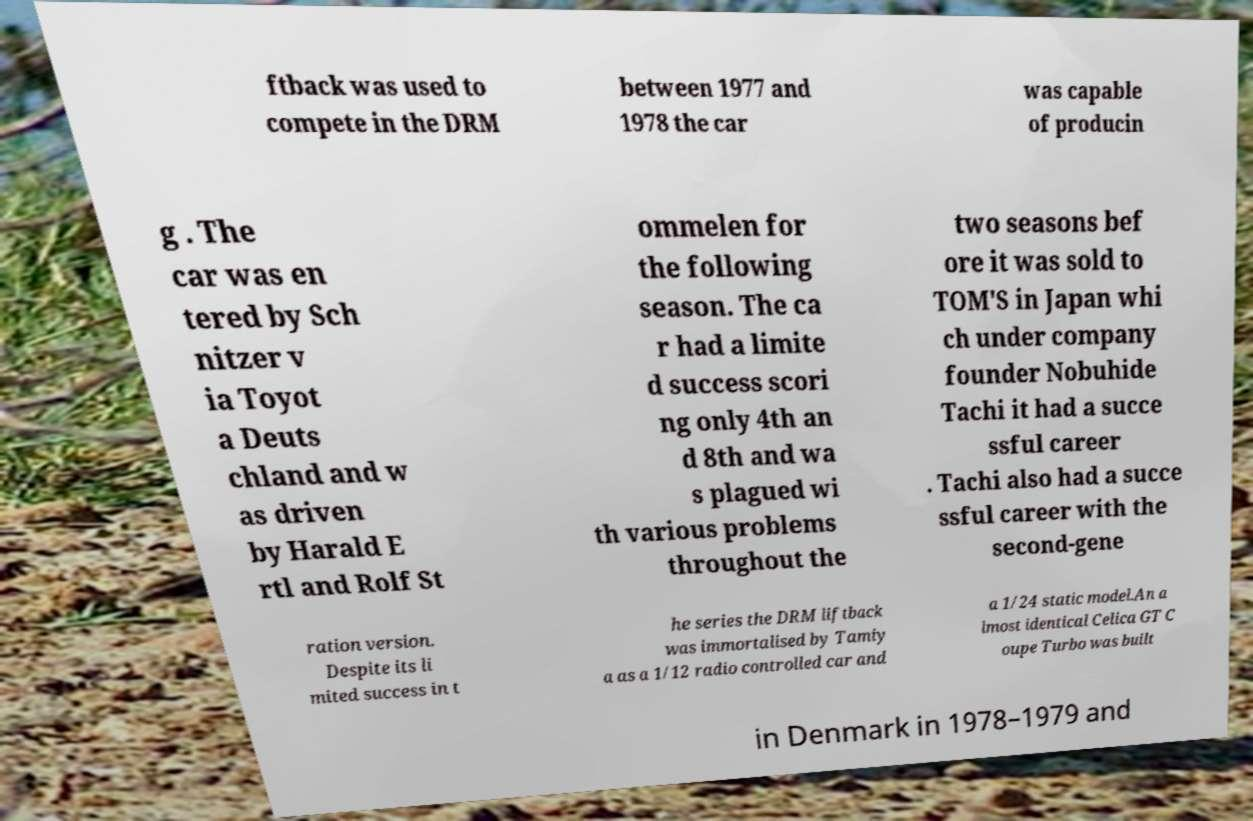Can you accurately transcribe the text from the provided image for me? ftback was used to compete in the DRM between 1977 and 1978 the car was capable of producin g . The car was en tered by Sch nitzer v ia Toyot a Deuts chland and w as driven by Harald E rtl and Rolf St ommelen for the following season. The ca r had a limite d success scori ng only 4th an d 8th and wa s plagued wi th various problems throughout the two seasons bef ore it was sold to TOM'S in Japan whi ch under company founder Nobuhide Tachi it had a succe ssful career . Tachi also had a succe ssful career with the second-gene ration version. Despite its li mited success in t he series the DRM liftback was immortalised by Tamiy a as a 1/12 radio controlled car and a 1/24 static model.An a lmost identical Celica GT C oupe Turbo was built in Denmark in 1978–1979 and 